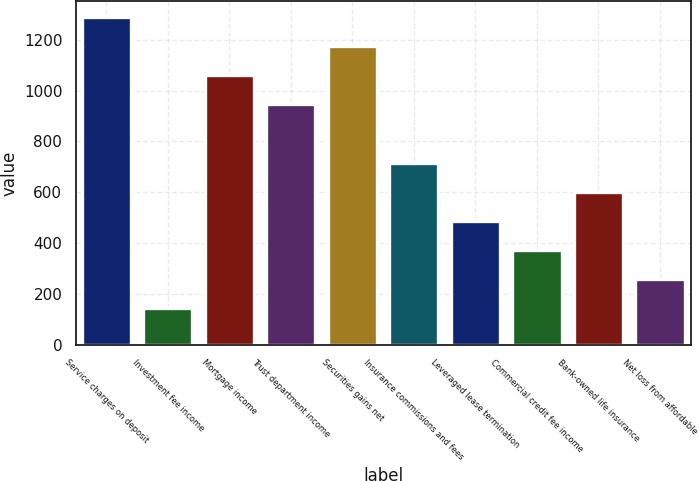<chart> <loc_0><loc_0><loc_500><loc_500><bar_chart><fcel>Service charges on deposit<fcel>Investment fee income<fcel>Mortgage income<fcel>Trust department income<fcel>Securities gains net<fcel>Insurance commissions and fees<fcel>Leveraged lease termination<fcel>Commercial credit fee income<fcel>Bank-owned life insurance<fcel>Net loss from affordable<nl><fcel>1288.3<fcel>145.3<fcel>1059.7<fcel>945.4<fcel>1174<fcel>716.8<fcel>488.2<fcel>373.9<fcel>602.5<fcel>259.6<nl></chart> 